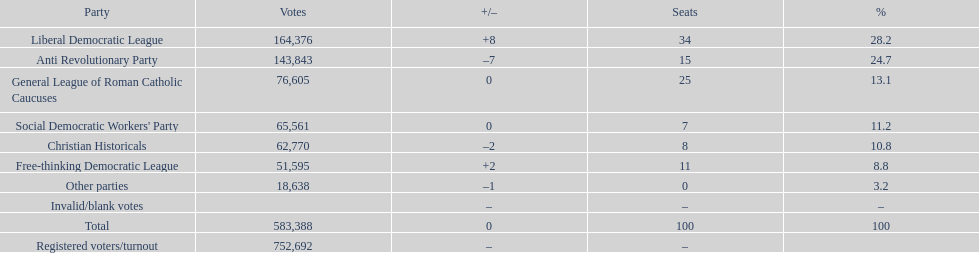How many votes were counted as invalid or blank votes? 0. 